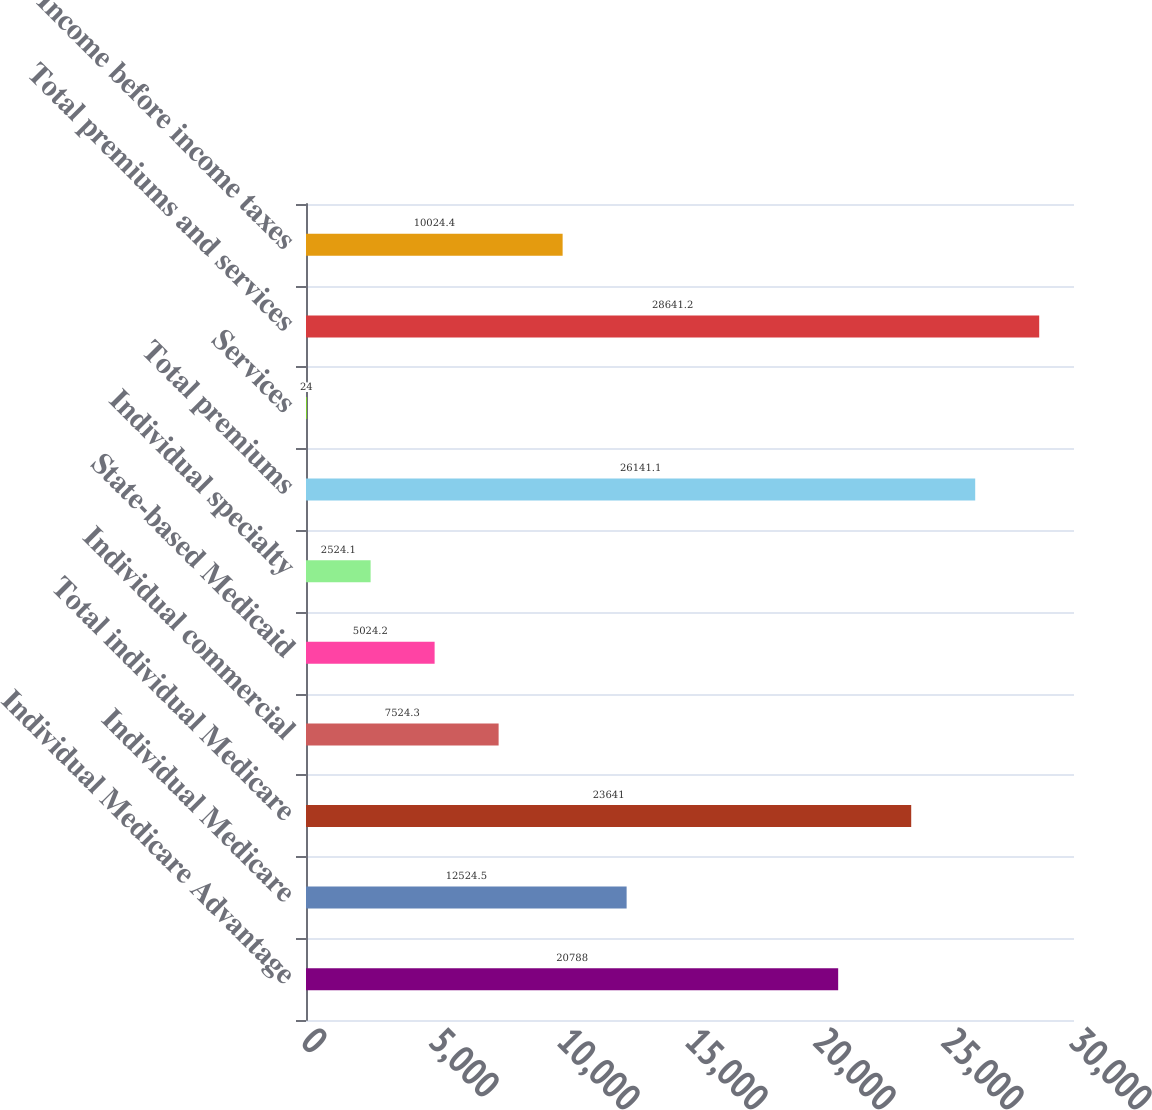Convert chart to OTSL. <chart><loc_0><loc_0><loc_500><loc_500><bar_chart><fcel>Individual Medicare Advantage<fcel>Individual Medicare<fcel>Total individual Medicare<fcel>Individual commercial<fcel>State-based Medicaid<fcel>Individual specialty<fcel>Total premiums<fcel>Services<fcel>Total premiums and services<fcel>Income before income taxes<nl><fcel>20788<fcel>12524.5<fcel>23641<fcel>7524.3<fcel>5024.2<fcel>2524.1<fcel>26141.1<fcel>24<fcel>28641.2<fcel>10024.4<nl></chart> 